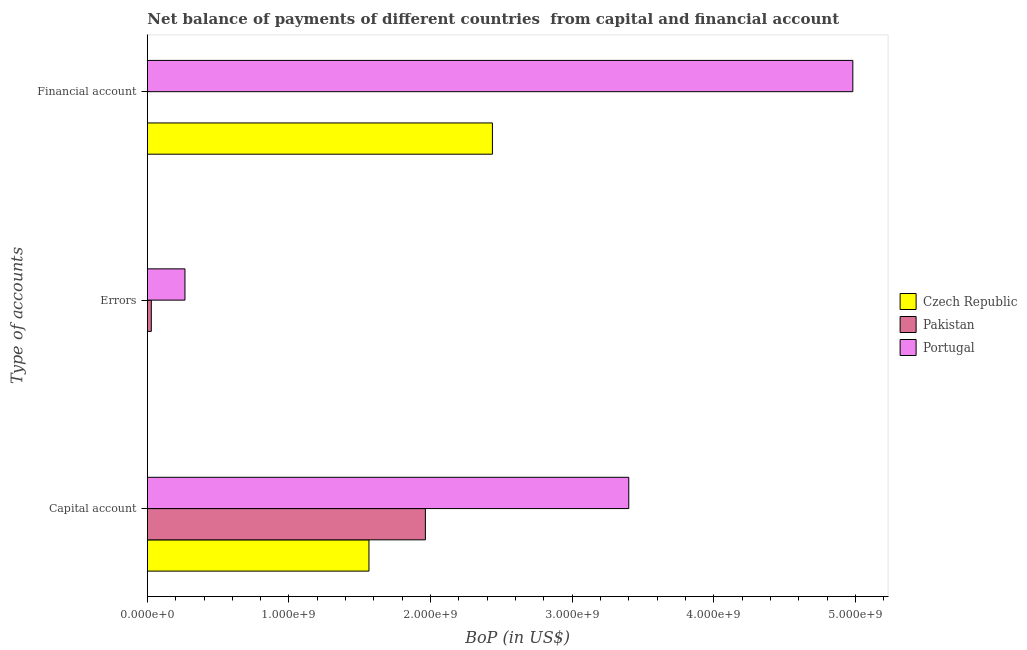How many different coloured bars are there?
Keep it short and to the point. 3. How many groups of bars are there?
Ensure brevity in your answer.  3. Are the number of bars per tick equal to the number of legend labels?
Give a very brief answer. No. What is the label of the 2nd group of bars from the top?
Your answer should be compact. Errors. What is the amount of net capital account in Portugal?
Make the answer very short. 3.40e+09. Across all countries, what is the maximum amount of errors?
Your answer should be compact. 2.66e+08. What is the total amount of net capital account in the graph?
Offer a terse response. 6.93e+09. What is the difference between the amount of financial account in Portugal and that in Czech Republic?
Offer a terse response. 2.54e+09. What is the difference between the amount of errors in Pakistan and the amount of net capital account in Portugal?
Offer a terse response. -3.37e+09. What is the average amount of financial account per country?
Offer a terse response. 2.47e+09. What is the difference between the amount of errors and amount of net capital account in Portugal?
Offer a very short reply. -3.13e+09. What is the ratio of the amount of net capital account in Czech Republic to that in Pakistan?
Offer a terse response. 0.8. Is the difference between the amount of net capital account in Pakistan and Portugal greater than the difference between the amount of errors in Pakistan and Portugal?
Provide a succinct answer. No. What is the difference between the highest and the second highest amount of net capital account?
Give a very brief answer. 1.44e+09. What is the difference between the highest and the lowest amount of net capital account?
Your response must be concise. 1.83e+09. How many bars are there?
Your answer should be compact. 7. How many countries are there in the graph?
Your response must be concise. 3. How many legend labels are there?
Provide a succinct answer. 3. What is the title of the graph?
Offer a very short reply. Net balance of payments of different countries  from capital and financial account. Does "Belize" appear as one of the legend labels in the graph?
Provide a succinct answer. No. What is the label or title of the X-axis?
Provide a succinct answer. BoP (in US$). What is the label or title of the Y-axis?
Make the answer very short. Type of accounts. What is the BoP (in US$) of Czech Republic in Capital account?
Give a very brief answer. 1.56e+09. What is the BoP (in US$) of Pakistan in Capital account?
Ensure brevity in your answer.  1.96e+09. What is the BoP (in US$) in Portugal in Capital account?
Provide a succinct answer. 3.40e+09. What is the BoP (in US$) of Czech Republic in Errors?
Offer a very short reply. 0. What is the BoP (in US$) of Pakistan in Errors?
Give a very brief answer. 2.80e+07. What is the BoP (in US$) in Portugal in Errors?
Your answer should be compact. 2.66e+08. What is the BoP (in US$) in Czech Republic in Financial account?
Your answer should be very brief. 2.44e+09. What is the BoP (in US$) in Portugal in Financial account?
Give a very brief answer. 4.98e+09. Across all Type of accounts, what is the maximum BoP (in US$) in Czech Republic?
Provide a succinct answer. 2.44e+09. Across all Type of accounts, what is the maximum BoP (in US$) of Pakistan?
Provide a short and direct response. 1.96e+09. Across all Type of accounts, what is the maximum BoP (in US$) of Portugal?
Offer a very short reply. 4.98e+09. Across all Type of accounts, what is the minimum BoP (in US$) of Pakistan?
Provide a succinct answer. 0. Across all Type of accounts, what is the minimum BoP (in US$) in Portugal?
Provide a succinct answer. 2.66e+08. What is the total BoP (in US$) in Czech Republic in the graph?
Ensure brevity in your answer.  4.00e+09. What is the total BoP (in US$) in Pakistan in the graph?
Keep it short and to the point. 1.99e+09. What is the total BoP (in US$) of Portugal in the graph?
Provide a short and direct response. 8.65e+09. What is the difference between the BoP (in US$) in Pakistan in Capital account and that in Errors?
Offer a terse response. 1.94e+09. What is the difference between the BoP (in US$) of Portugal in Capital account and that in Errors?
Offer a terse response. 3.13e+09. What is the difference between the BoP (in US$) of Czech Republic in Capital account and that in Financial account?
Provide a succinct answer. -8.72e+08. What is the difference between the BoP (in US$) of Portugal in Capital account and that in Financial account?
Your response must be concise. -1.58e+09. What is the difference between the BoP (in US$) in Portugal in Errors and that in Financial account?
Keep it short and to the point. -4.72e+09. What is the difference between the BoP (in US$) in Czech Republic in Capital account and the BoP (in US$) in Pakistan in Errors?
Offer a very short reply. 1.54e+09. What is the difference between the BoP (in US$) of Czech Republic in Capital account and the BoP (in US$) of Portugal in Errors?
Offer a very short reply. 1.30e+09. What is the difference between the BoP (in US$) in Pakistan in Capital account and the BoP (in US$) in Portugal in Errors?
Your response must be concise. 1.70e+09. What is the difference between the BoP (in US$) of Czech Republic in Capital account and the BoP (in US$) of Portugal in Financial account?
Your answer should be very brief. -3.42e+09. What is the difference between the BoP (in US$) of Pakistan in Capital account and the BoP (in US$) of Portugal in Financial account?
Ensure brevity in your answer.  -3.02e+09. What is the difference between the BoP (in US$) of Pakistan in Errors and the BoP (in US$) of Portugal in Financial account?
Provide a short and direct response. -4.95e+09. What is the average BoP (in US$) in Czech Republic per Type of accounts?
Offer a very short reply. 1.33e+09. What is the average BoP (in US$) in Pakistan per Type of accounts?
Make the answer very short. 6.64e+08. What is the average BoP (in US$) of Portugal per Type of accounts?
Keep it short and to the point. 2.88e+09. What is the difference between the BoP (in US$) in Czech Republic and BoP (in US$) in Pakistan in Capital account?
Provide a short and direct response. -3.98e+08. What is the difference between the BoP (in US$) in Czech Republic and BoP (in US$) in Portugal in Capital account?
Make the answer very short. -1.83e+09. What is the difference between the BoP (in US$) in Pakistan and BoP (in US$) in Portugal in Capital account?
Provide a succinct answer. -1.44e+09. What is the difference between the BoP (in US$) in Pakistan and BoP (in US$) in Portugal in Errors?
Offer a very short reply. -2.38e+08. What is the difference between the BoP (in US$) in Czech Republic and BoP (in US$) in Portugal in Financial account?
Give a very brief answer. -2.54e+09. What is the ratio of the BoP (in US$) in Pakistan in Capital account to that in Errors?
Ensure brevity in your answer.  70.11. What is the ratio of the BoP (in US$) in Portugal in Capital account to that in Errors?
Provide a short and direct response. 12.8. What is the ratio of the BoP (in US$) in Czech Republic in Capital account to that in Financial account?
Offer a terse response. 0.64. What is the ratio of the BoP (in US$) in Portugal in Capital account to that in Financial account?
Ensure brevity in your answer.  0.68. What is the ratio of the BoP (in US$) in Portugal in Errors to that in Financial account?
Make the answer very short. 0.05. What is the difference between the highest and the second highest BoP (in US$) in Portugal?
Your answer should be compact. 1.58e+09. What is the difference between the highest and the lowest BoP (in US$) in Czech Republic?
Provide a succinct answer. 2.44e+09. What is the difference between the highest and the lowest BoP (in US$) in Pakistan?
Your response must be concise. 1.96e+09. What is the difference between the highest and the lowest BoP (in US$) in Portugal?
Ensure brevity in your answer.  4.72e+09. 